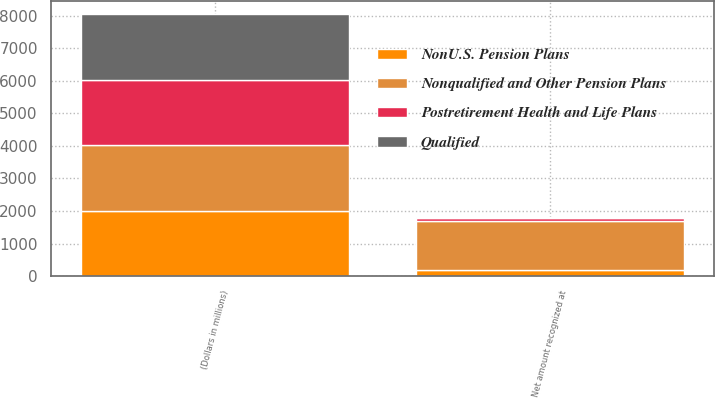Convert chart to OTSL. <chart><loc_0><loc_0><loc_500><loc_500><stacked_bar_chart><ecel><fcel>(Dollars in millions)<fcel>Net amount recognized at<nl><fcel>NonU.S. Pension Plans<fcel>2011<fcel>179<nl><fcel>Qualified<fcel>2011<fcel>38<nl><fcel>Postretirement Health and Life Plans<fcel>2011<fcel>76<nl><fcel>Nonqualified and Other Pension Plans<fcel>2011<fcel>1528<nl></chart> 